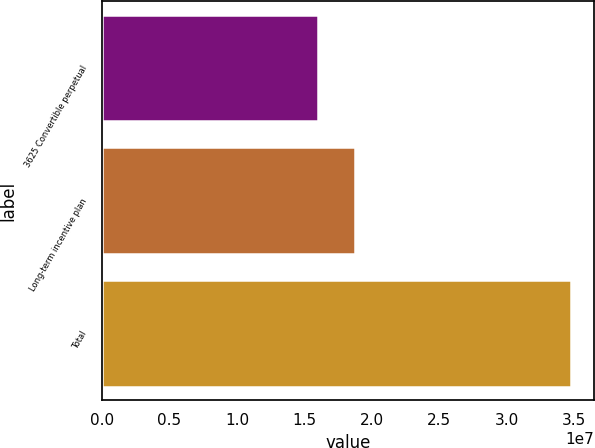Convert chart to OTSL. <chart><loc_0><loc_0><loc_500><loc_500><bar_chart><fcel>3625 Convertible perpetual<fcel>Long-term incentive plan<fcel>Total<nl><fcel>1.6e+07<fcel>1.87509e+07<fcel>3.47509e+07<nl></chart> 